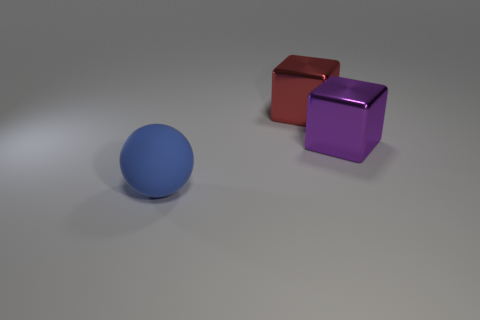Add 1 big blue balls. How many objects exist? 4 Subtract all cubes. How many objects are left? 1 Subtract all small cyan rubber cubes. Subtract all large objects. How many objects are left? 0 Add 2 large balls. How many large balls are left? 3 Add 2 tiny purple cylinders. How many tiny purple cylinders exist? 2 Subtract 0 gray cubes. How many objects are left? 3 Subtract all brown cubes. Subtract all red balls. How many cubes are left? 2 